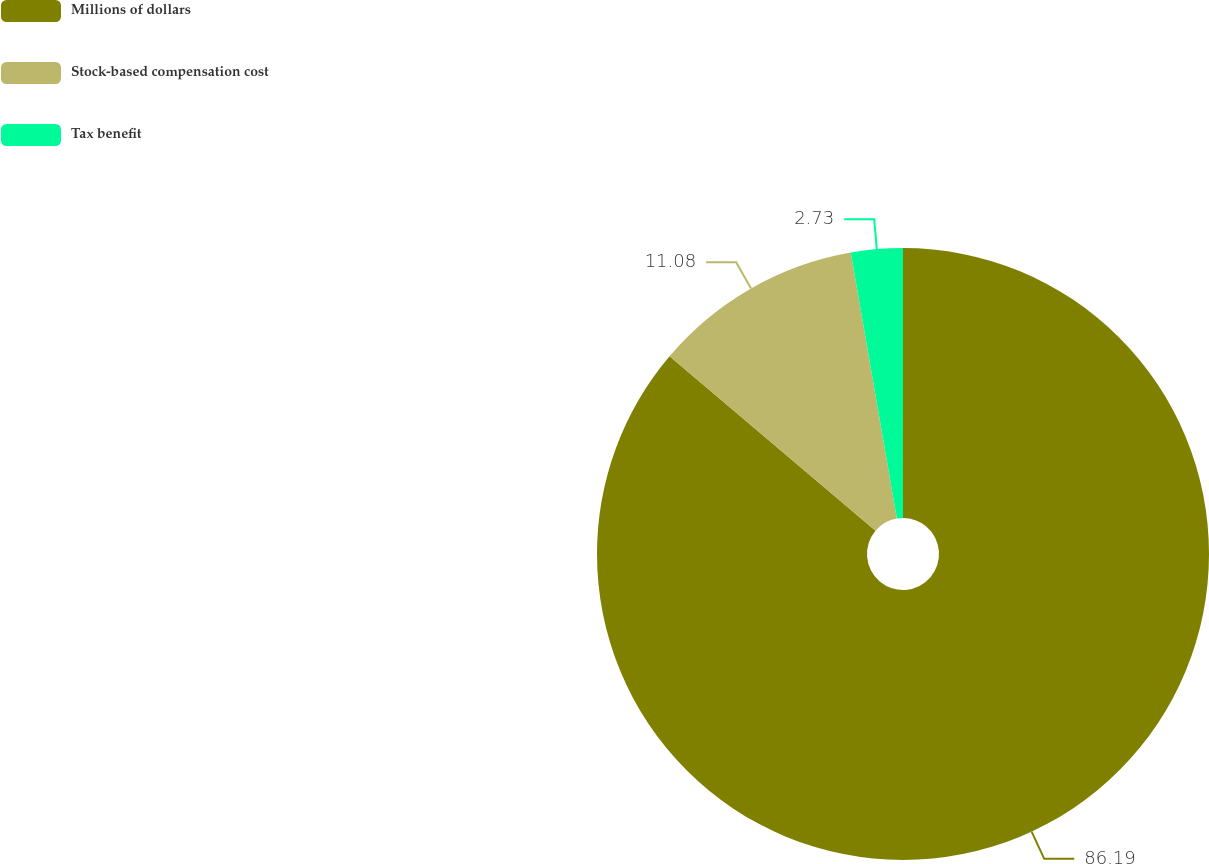Convert chart. <chart><loc_0><loc_0><loc_500><loc_500><pie_chart><fcel>Millions of dollars<fcel>Stock-based compensation cost<fcel>Tax benefit<nl><fcel>86.19%<fcel>11.08%<fcel>2.73%<nl></chart> 